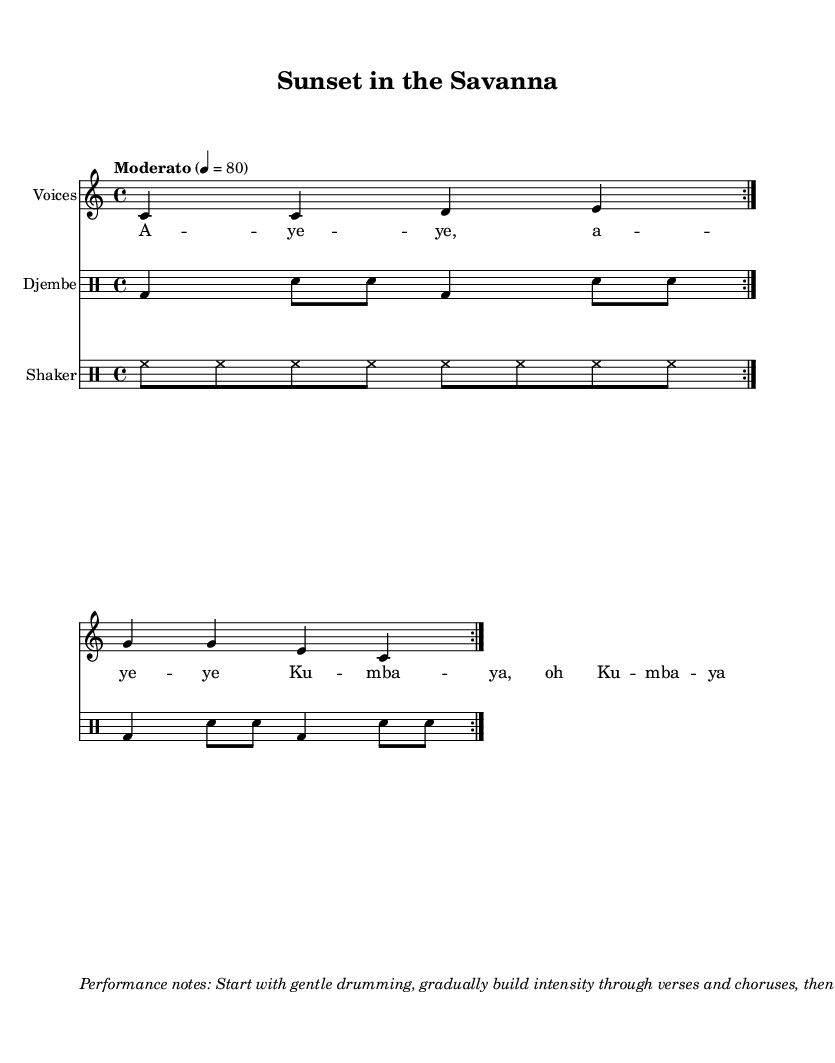What is the key signature of this music? The key signature is indicated at the beginning of the score and shows no sharps or flats, confirming it is in C major.
Answer: C major What is the time signature of the piece? The time signature is noted after the key signature, which indicates that each measure has four beats, so it’s 4/4.
Answer: 4/4 What is the tempo marking for this composition? The tempo marking is written at the beginning of the score, which states "Moderato" with a metronome mark of 80 beats per minute.
Answer: Moderato, 80 How many times is the drum pattern repeated? The drum pattern is shown with the instruction "repeat volta 2," which indicates that it should be repeated two times.
Answer: 2 What instruments are featured in this piece? The score lists three parts, including one for "Voices," one for "Djembe," and another for "Shaker," indicating that these are the featured instruments.
Answer: Voices, Djembe, Shaker What is the function of the chant in this music? The chant consists of melodic phrases sung by voices, which enhances the piece with a call and response nature typical in traditional African music, allowing for relaxation and connection.
Answer: Call and response What effect should the performance create according to the notes? The performance notes describe a gradual build-up of intensity followed by a calming decrease, which aims to facilitate relaxation after a busy day.
Answer: Calming effect 